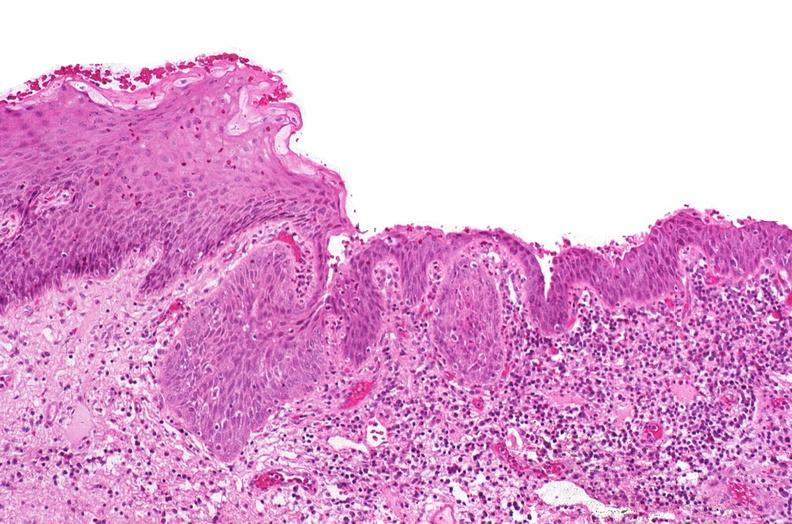does this image show renal pelvis, squamous metaplasia due to chronic urolithiasis?
Answer the question using a single word or phrase. Yes 